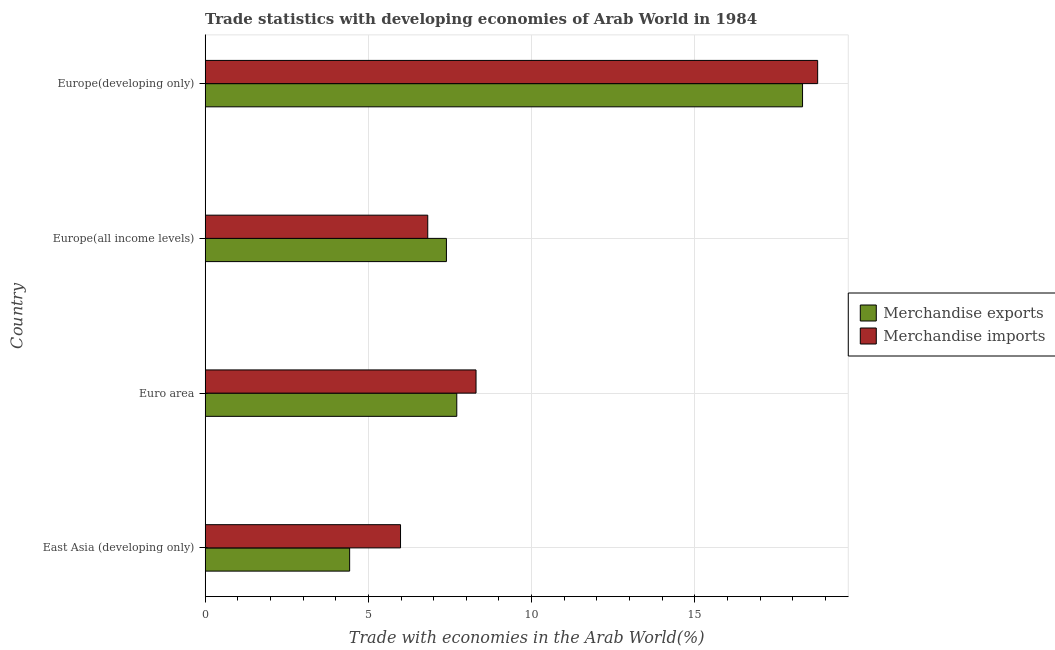How many groups of bars are there?
Your answer should be very brief. 4. What is the label of the 1st group of bars from the top?
Offer a terse response. Europe(developing only). In how many cases, is the number of bars for a given country not equal to the number of legend labels?
Keep it short and to the point. 0. What is the merchandise exports in Euro area?
Your answer should be very brief. 7.71. Across all countries, what is the maximum merchandise exports?
Give a very brief answer. 18.3. Across all countries, what is the minimum merchandise imports?
Provide a succinct answer. 5.98. In which country was the merchandise imports maximum?
Make the answer very short. Europe(developing only). In which country was the merchandise imports minimum?
Ensure brevity in your answer.  East Asia (developing only). What is the total merchandise imports in the graph?
Your answer should be compact. 39.86. What is the difference between the merchandise imports in East Asia (developing only) and that in Europe(developing only)?
Offer a terse response. -12.78. What is the difference between the merchandise exports in Europe(all income levels) and the merchandise imports in East Asia (developing only)?
Make the answer very short. 1.41. What is the average merchandise exports per country?
Your answer should be compact. 9.46. What is the difference between the merchandise exports and merchandise imports in East Asia (developing only)?
Provide a short and direct response. -1.56. What is the ratio of the merchandise exports in Europe(all income levels) to that in Europe(developing only)?
Provide a short and direct response. 0.4. Is the difference between the merchandise imports in Europe(all income levels) and Europe(developing only) greater than the difference between the merchandise exports in Europe(all income levels) and Europe(developing only)?
Your answer should be compact. No. What is the difference between the highest and the second highest merchandise imports?
Your answer should be very brief. 10.47. What is the difference between the highest and the lowest merchandise imports?
Give a very brief answer. 12.78. What does the 2nd bar from the top in Europe(all income levels) represents?
Ensure brevity in your answer.  Merchandise exports. Are all the bars in the graph horizontal?
Your response must be concise. Yes. Does the graph contain any zero values?
Your answer should be compact. No. Where does the legend appear in the graph?
Offer a very short reply. Center right. How many legend labels are there?
Ensure brevity in your answer.  2. What is the title of the graph?
Your answer should be very brief. Trade statistics with developing economies of Arab World in 1984. What is the label or title of the X-axis?
Provide a short and direct response. Trade with economies in the Arab World(%). What is the Trade with economies in the Arab World(%) in Merchandise exports in East Asia (developing only)?
Provide a succinct answer. 4.43. What is the Trade with economies in the Arab World(%) of Merchandise imports in East Asia (developing only)?
Your response must be concise. 5.98. What is the Trade with economies in the Arab World(%) in Merchandise exports in Euro area?
Ensure brevity in your answer.  7.71. What is the Trade with economies in the Arab World(%) of Merchandise imports in Euro area?
Keep it short and to the point. 8.3. What is the Trade with economies in the Arab World(%) in Merchandise exports in Europe(all income levels)?
Offer a very short reply. 7.39. What is the Trade with economies in the Arab World(%) of Merchandise imports in Europe(all income levels)?
Keep it short and to the point. 6.82. What is the Trade with economies in the Arab World(%) of Merchandise exports in Europe(developing only)?
Keep it short and to the point. 18.3. What is the Trade with economies in the Arab World(%) of Merchandise imports in Europe(developing only)?
Give a very brief answer. 18.76. Across all countries, what is the maximum Trade with economies in the Arab World(%) in Merchandise exports?
Make the answer very short. 18.3. Across all countries, what is the maximum Trade with economies in the Arab World(%) of Merchandise imports?
Ensure brevity in your answer.  18.76. Across all countries, what is the minimum Trade with economies in the Arab World(%) in Merchandise exports?
Your response must be concise. 4.43. Across all countries, what is the minimum Trade with economies in the Arab World(%) in Merchandise imports?
Provide a succinct answer. 5.98. What is the total Trade with economies in the Arab World(%) of Merchandise exports in the graph?
Make the answer very short. 37.82. What is the total Trade with economies in the Arab World(%) of Merchandise imports in the graph?
Your response must be concise. 39.86. What is the difference between the Trade with economies in the Arab World(%) in Merchandise exports in East Asia (developing only) and that in Euro area?
Provide a short and direct response. -3.28. What is the difference between the Trade with economies in the Arab World(%) of Merchandise imports in East Asia (developing only) and that in Euro area?
Your answer should be very brief. -2.31. What is the difference between the Trade with economies in the Arab World(%) in Merchandise exports in East Asia (developing only) and that in Europe(all income levels)?
Offer a terse response. -2.97. What is the difference between the Trade with economies in the Arab World(%) of Merchandise imports in East Asia (developing only) and that in Europe(all income levels)?
Your answer should be compact. -0.83. What is the difference between the Trade with economies in the Arab World(%) in Merchandise exports in East Asia (developing only) and that in Europe(developing only)?
Ensure brevity in your answer.  -13.88. What is the difference between the Trade with economies in the Arab World(%) in Merchandise imports in East Asia (developing only) and that in Europe(developing only)?
Offer a very short reply. -12.78. What is the difference between the Trade with economies in the Arab World(%) in Merchandise exports in Euro area and that in Europe(all income levels)?
Offer a terse response. 0.32. What is the difference between the Trade with economies in the Arab World(%) of Merchandise imports in Euro area and that in Europe(all income levels)?
Your answer should be compact. 1.48. What is the difference between the Trade with economies in the Arab World(%) of Merchandise exports in Euro area and that in Europe(developing only)?
Provide a short and direct response. -10.59. What is the difference between the Trade with economies in the Arab World(%) of Merchandise imports in Euro area and that in Europe(developing only)?
Ensure brevity in your answer.  -10.47. What is the difference between the Trade with economies in the Arab World(%) in Merchandise exports in Europe(all income levels) and that in Europe(developing only)?
Your response must be concise. -10.91. What is the difference between the Trade with economies in the Arab World(%) of Merchandise imports in Europe(all income levels) and that in Europe(developing only)?
Your answer should be compact. -11.95. What is the difference between the Trade with economies in the Arab World(%) in Merchandise exports in East Asia (developing only) and the Trade with economies in the Arab World(%) in Merchandise imports in Euro area?
Make the answer very short. -3.87. What is the difference between the Trade with economies in the Arab World(%) in Merchandise exports in East Asia (developing only) and the Trade with economies in the Arab World(%) in Merchandise imports in Europe(all income levels)?
Make the answer very short. -2.39. What is the difference between the Trade with economies in the Arab World(%) of Merchandise exports in East Asia (developing only) and the Trade with economies in the Arab World(%) of Merchandise imports in Europe(developing only)?
Ensure brevity in your answer.  -14.34. What is the difference between the Trade with economies in the Arab World(%) of Merchandise exports in Euro area and the Trade with economies in the Arab World(%) of Merchandise imports in Europe(all income levels)?
Offer a very short reply. 0.89. What is the difference between the Trade with economies in the Arab World(%) in Merchandise exports in Euro area and the Trade with economies in the Arab World(%) in Merchandise imports in Europe(developing only)?
Ensure brevity in your answer.  -11.06. What is the difference between the Trade with economies in the Arab World(%) in Merchandise exports in Europe(all income levels) and the Trade with economies in the Arab World(%) in Merchandise imports in Europe(developing only)?
Provide a short and direct response. -11.37. What is the average Trade with economies in the Arab World(%) in Merchandise exports per country?
Provide a short and direct response. 9.46. What is the average Trade with economies in the Arab World(%) of Merchandise imports per country?
Your response must be concise. 9.97. What is the difference between the Trade with economies in the Arab World(%) of Merchandise exports and Trade with economies in the Arab World(%) of Merchandise imports in East Asia (developing only)?
Ensure brevity in your answer.  -1.56. What is the difference between the Trade with economies in the Arab World(%) of Merchandise exports and Trade with economies in the Arab World(%) of Merchandise imports in Euro area?
Give a very brief answer. -0.59. What is the difference between the Trade with economies in the Arab World(%) of Merchandise exports and Trade with economies in the Arab World(%) of Merchandise imports in Europe(all income levels)?
Provide a succinct answer. 0.57. What is the difference between the Trade with economies in the Arab World(%) in Merchandise exports and Trade with economies in the Arab World(%) in Merchandise imports in Europe(developing only)?
Your answer should be very brief. -0.46. What is the ratio of the Trade with economies in the Arab World(%) of Merchandise exports in East Asia (developing only) to that in Euro area?
Provide a succinct answer. 0.57. What is the ratio of the Trade with economies in the Arab World(%) of Merchandise imports in East Asia (developing only) to that in Euro area?
Give a very brief answer. 0.72. What is the ratio of the Trade with economies in the Arab World(%) of Merchandise exports in East Asia (developing only) to that in Europe(all income levels)?
Ensure brevity in your answer.  0.6. What is the ratio of the Trade with economies in the Arab World(%) of Merchandise imports in East Asia (developing only) to that in Europe(all income levels)?
Your answer should be very brief. 0.88. What is the ratio of the Trade with economies in the Arab World(%) of Merchandise exports in East Asia (developing only) to that in Europe(developing only)?
Make the answer very short. 0.24. What is the ratio of the Trade with economies in the Arab World(%) in Merchandise imports in East Asia (developing only) to that in Europe(developing only)?
Give a very brief answer. 0.32. What is the ratio of the Trade with economies in the Arab World(%) of Merchandise exports in Euro area to that in Europe(all income levels)?
Make the answer very short. 1.04. What is the ratio of the Trade with economies in the Arab World(%) of Merchandise imports in Euro area to that in Europe(all income levels)?
Offer a very short reply. 1.22. What is the ratio of the Trade with economies in the Arab World(%) of Merchandise exports in Euro area to that in Europe(developing only)?
Offer a terse response. 0.42. What is the ratio of the Trade with economies in the Arab World(%) of Merchandise imports in Euro area to that in Europe(developing only)?
Offer a terse response. 0.44. What is the ratio of the Trade with economies in the Arab World(%) in Merchandise exports in Europe(all income levels) to that in Europe(developing only)?
Provide a short and direct response. 0.4. What is the ratio of the Trade with economies in the Arab World(%) of Merchandise imports in Europe(all income levels) to that in Europe(developing only)?
Your response must be concise. 0.36. What is the difference between the highest and the second highest Trade with economies in the Arab World(%) in Merchandise exports?
Ensure brevity in your answer.  10.59. What is the difference between the highest and the second highest Trade with economies in the Arab World(%) of Merchandise imports?
Offer a terse response. 10.47. What is the difference between the highest and the lowest Trade with economies in the Arab World(%) of Merchandise exports?
Your answer should be very brief. 13.88. What is the difference between the highest and the lowest Trade with economies in the Arab World(%) of Merchandise imports?
Your response must be concise. 12.78. 